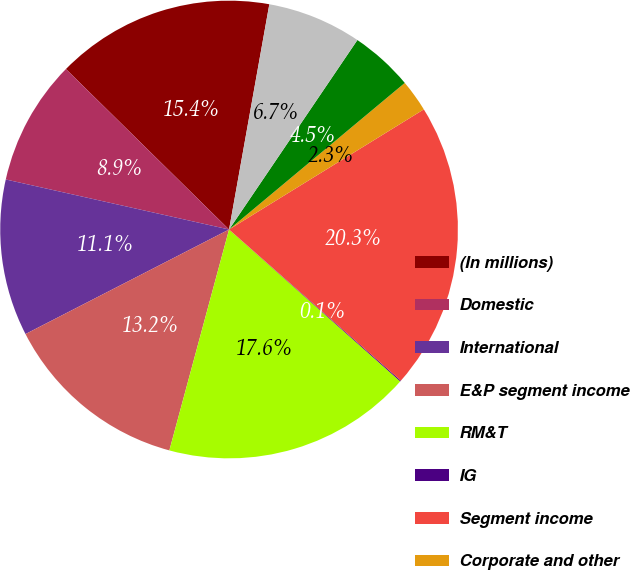Convert chart. <chart><loc_0><loc_0><loc_500><loc_500><pie_chart><fcel>(In millions)<fcel>Domestic<fcel>International<fcel>E&P segment income<fcel>RM&T<fcel>IG<fcel>Segment income<fcel>Corporate and other<fcel>Gain (loss) on long-term UK<fcel>Discontinued operations<nl><fcel>15.45%<fcel>8.86%<fcel>11.06%<fcel>13.25%<fcel>17.65%<fcel>0.07%<fcel>20.28%<fcel>2.27%<fcel>4.46%<fcel>6.66%<nl></chart> 